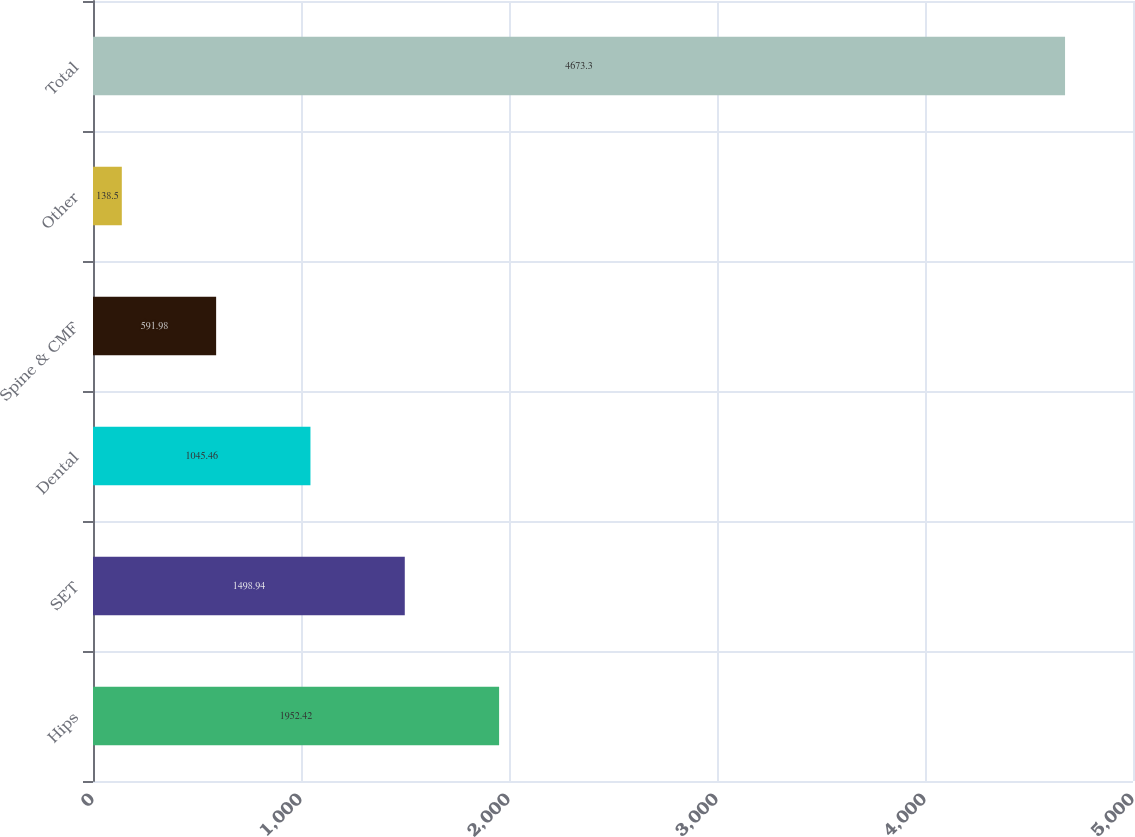<chart> <loc_0><loc_0><loc_500><loc_500><bar_chart><fcel>Hips<fcel>SET<fcel>Dental<fcel>Spine & CMF<fcel>Other<fcel>Total<nl><fcel>1952.42<fcel>1498.94<fcel>1045.46<fcel>591.98<fcel>138.5<fcel>4673.3<nl></chart> 